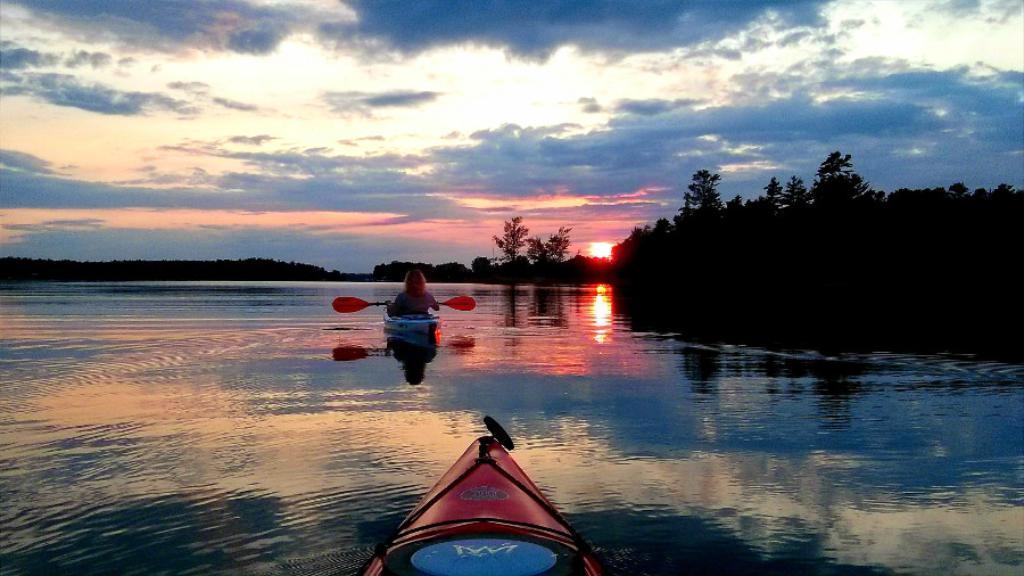Please provide a concise description of this image. This is the picture of a river. In this image there are boats on the water and there is a person sitting on the boat. At the back there are trees. At the top there is sky and there are clouds and there is a sun. At the bottom there is water. 